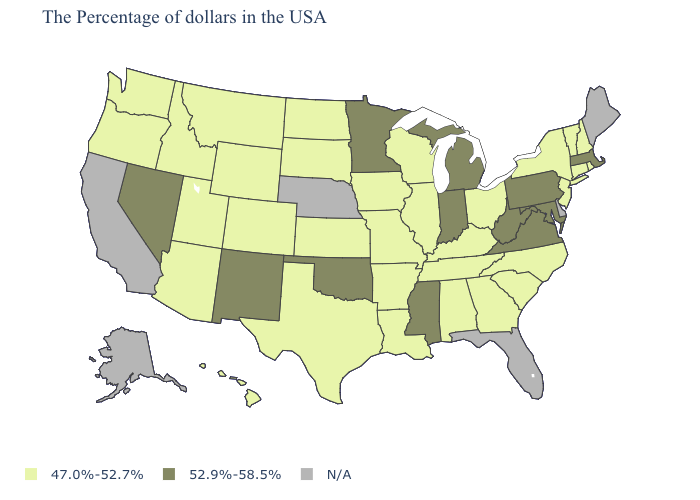Name the states that have a value in the range 47.0%-52.7%?
Quick response, please. Rhode Island, New Hampshire, Vermont, Connecticut, New York, New Jersey, North Carolina, South Carolina, Ohio, Georgia, Kentucky, Alabama, Tennessee, Wisconsin, Illinois, Louisiana, Missouri, Arkansas, Iowa, Kansas, Texas, South Dakota, North Dakota, Wyoming, Colorado, Utah, Montana, Arizona, Idaho, Washington, Oregon, Hawaii. What is the lowest value in the West?
Concise answer only. 47.0%-52.7%. What is the lowest value in the MidWest?
Be succinct. 47.0%-52.7%. What is the value of Ohio?
Write a very short answer. 47.0%-52.7%. What is the value of Maryland?
Give a very brief answer. 52.9%-58.5%. What is the value of West Virginia?
Answer briefly. 52.9%-58.5%. Is the legend a continuous bar?
Be succinct. No. What is the value of Mississippi?
Keep it brief. 52.9%-58.5%. Name the states that have a value in the range 52.9%-58.5%?
Be succinct. Massachusetts, Maryland, Pennsylvania, Virginia, West Virginia, Michigan, Indiana, Mississippi, Minnesota, Oklahoma, New Mexico, Nevada. What is the lowest value in the MidWest?
Be succinct. 47.0%-52.7%. Among the states that border Colorado , does New Mexico have the highest value?
Keep it brief. Yes. Which states hav the highest value in the West?
Be succinct. New Mexico, Nevada. Does New Jersey have the highest value in the USA?
Keep it brief. No. 